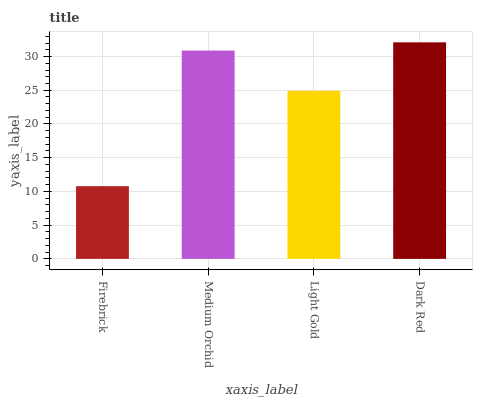Is Firebrick the minimum?
Answer yes or no. Yes. Is Dark Red the maximum?
Answer yes or no. Yes. Is Medium Orchid the minimum?
Answer yes or no. No. Is Medium Orchid the maximum?
Answer yes or no. No. Is Medium Orchid greater than Firebrick?
Answer yes or no. Yes. Is Firebrick less than Medium Orchid?
Answer yes or no. Yes. Is Firebrick greater than Medium Orchid?
Answer yes or no. No. Is Medium Orchid less than Firebrick?
Answer yes or no. No. Is Medium Orchid the high median?
Answer yes or no. Yes. Is Light Gold the low median?
Answer yes or no. Yes. Is Dark Red the high median?
Answer yes or no. No. Is Dark Red the low median?
Answer yes or no. No. 